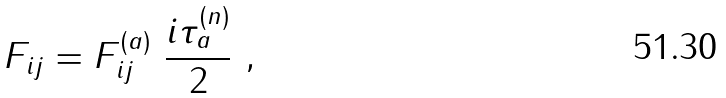Convert formula to latex. <formula><loc_0><loc_0><loc_500><loc_500>F _ { i j } = F ^ { ( a ) } _ { i j } \ \frac { i \tau _ { a } ^ { ( n ) } } { 2 } \ ,</formula> 